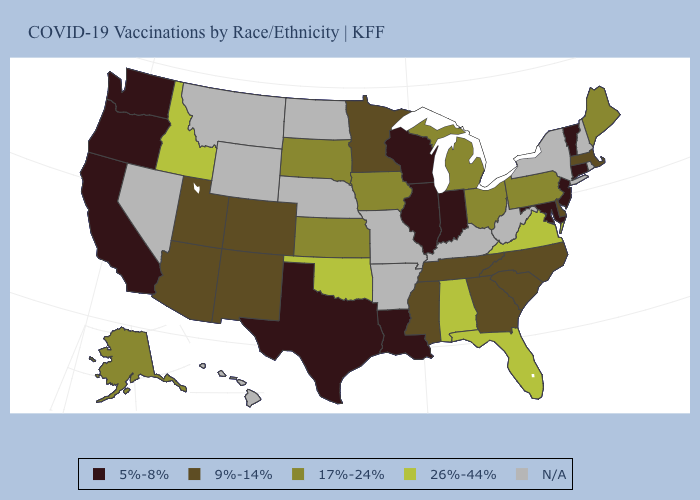What is the value of Connecticut?
Give a very brief answer. 5%-8%. What is the lowest value in the USA?
Answer briefly. 5%-8%. Which states have the highest value in the USA?
Quick response, please. Alabama, Florida, Idaho, Oklahoma, Virginia. Name the states that have a value in the range 5%-8%?
Concise answer only. California, Connecticut, Illinois, Indiana, Louisiana, Maryland, New Jersey, Oregon, Texas, Vermont, Washington, Wisconsin. Name the states that have a value in the range 26%-44%?
Concise answer only. Alabama, Florida, Idaho, Oklahoma, Virginia. Which states hav the highest value in the Northeast?
Be succinct. Maine, Pennsylvania. What is the lowest value in states that border Rhode Island?
Concise answer only. 5%-8%. Name the states that have a value in the range 9%-14%?
Quick response, please. Arizona, Colorado, Delaware, Georgia, Massachusetts, Minnesota, Mississippi, New Mexico, North Carolina, South Carolina, Tennessee, Utah. Name the states that have a value in the range 26%-44%?
Concise answer only. Alabama, Florida, Idaho, Oklahoma, Virginia. Name the states that have a value in the range 26%-44%?
Write a very short answer. Alabama, Florida, Idaho, Oklahoma, Virginia. Does Kansas have the lowest value in the MidWest?
Write a very short answer. No. Name the states that have a value in the range 26%-44%?
Quick response, please. Alabama, Florida, Idaho, Oklahoma, Virginia. Which states have the highest value in the USA?
Write a very short answer. Alabama, Florida, Idaho, Oklahoma, Virginia. Name the states that have a value in the range 26%-44%?
Keep it brief. Alabama, Florida, Idaho, Oklahoma, Virginia. Name the states that have a value in the range 26%-44%?
Write a very short answer. Alabama, Florida, Idaho, Oklahoma, Virginia. 